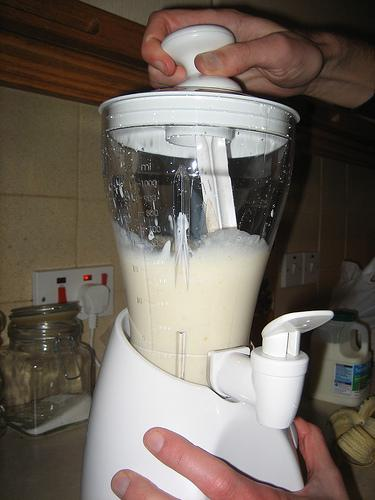Question: how are they mixing the liquid?
Choices:
A. Blender.
B. A spoon.
C. A stirrer.
D. A whisk.
Answer with the letter. Answer: C Question: what are is being done?
Choices:
A. Mixing.
B. Painting.
C. Dancing.
D. Cooking.
Answer with the letter. Answer: A Question: where is this in a house?
Choices:
A. Den.
B. Bedroom.
C. Kitchen.
D. Bathroom.
Answer with the letter. Answer: C Question: what white liquid can be seen in the background?
Choices:
A. Milk.
B. Cream.
C. Soy milk.
D. Almond milk.
Answer with the letter. Answer: A Question: why are they mixing this?
Choices:
A. To drink.
B. To cook with it.
C. To make concrete.
D. A recipe calls for it.
Answer with the letter. Answer: A Question: what fruit is on the table?
Choices:
A. Apple.
B. Banana.
C. Orange.
D. Kiwi.
Answer with the letter. Answer: B 